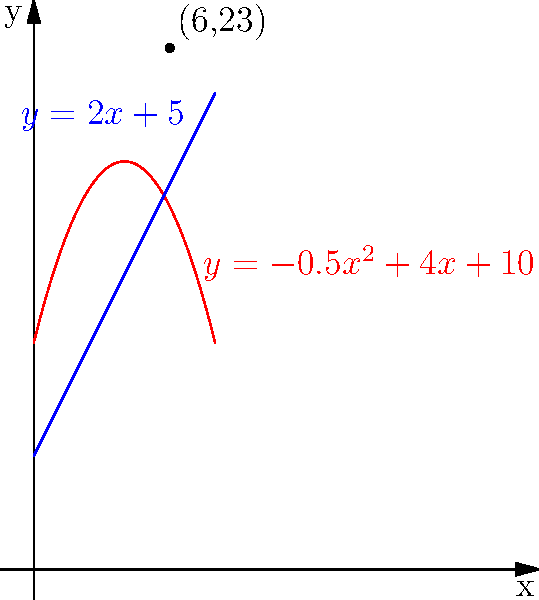As an ammunition supplier, you're designing a new storage container with a curved top and a flat bottom. The curved top is modeled by the equation $y=-0.5x^2+4x+10$, and the flat bottom by $y=2x+5$, where $x$ and $y$ are in feet. What is the maximum height of the container, and at what horizontal distance from the left edge does this occur? To find the maximum height of the container and its location, we need to follow these steps:

1) The height of the container at any point $x$ is the difference between the top and bottom equations:
   $h(x) = (-0.5x^2+4x+10) - (2x+5) = -0.5x^2+2x+5$

2) To find the maximum height, we need to find the vertex of this parabola. For a quadratic function in the form $ax^2+bx+c$, the x-coordinate of the vertex is given by $x = -\frac{b}{2a}$

3) In our case, $a=-0.5$, $b=2$, so:
   $x = -\frac{2}{2(-0.5)} = -\frac{2}{-1} = 2$

4) To find the y-coordinate (maximum height), we plug this x-value back into our height function:
   $h(2) = -0.5(2)^2 + 2(2) + 5 = -2 + 4 + 5 = 7$

5) Therefore, the maximum height occurs 2 feet from the left edge and the height at this point is 7 feet.

6) We can verify this visually from the graph, where the point (6,23) is marked. This point represents where the curves intersect 6 feet from the left edge, not where the maximum height occurs.
Answer: Maximum height: 7 feet, occurring 2 feet from the left edge. 